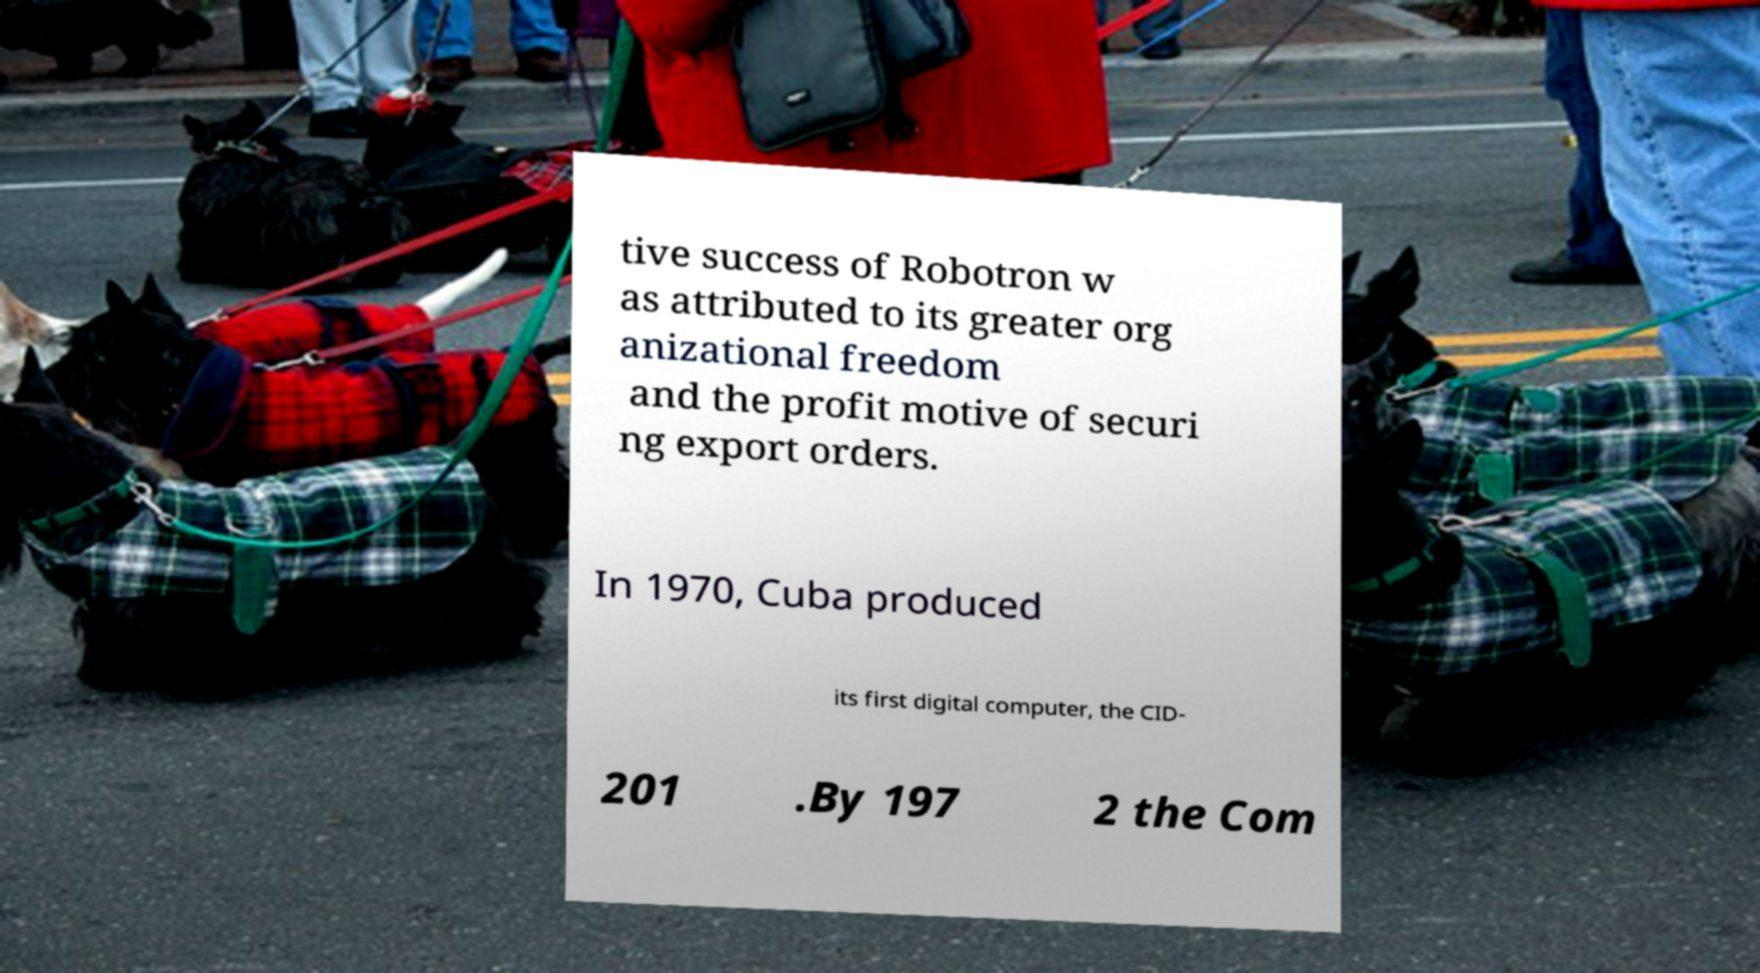Could you extract and type out the text from this image? tive success of Robotron w as attributed to its greater org anizational freedom and the profit motive of securi ng export orders. In 1970, Cuba produced its first digital computer, the CID- 201 .By 197 2 the Com 